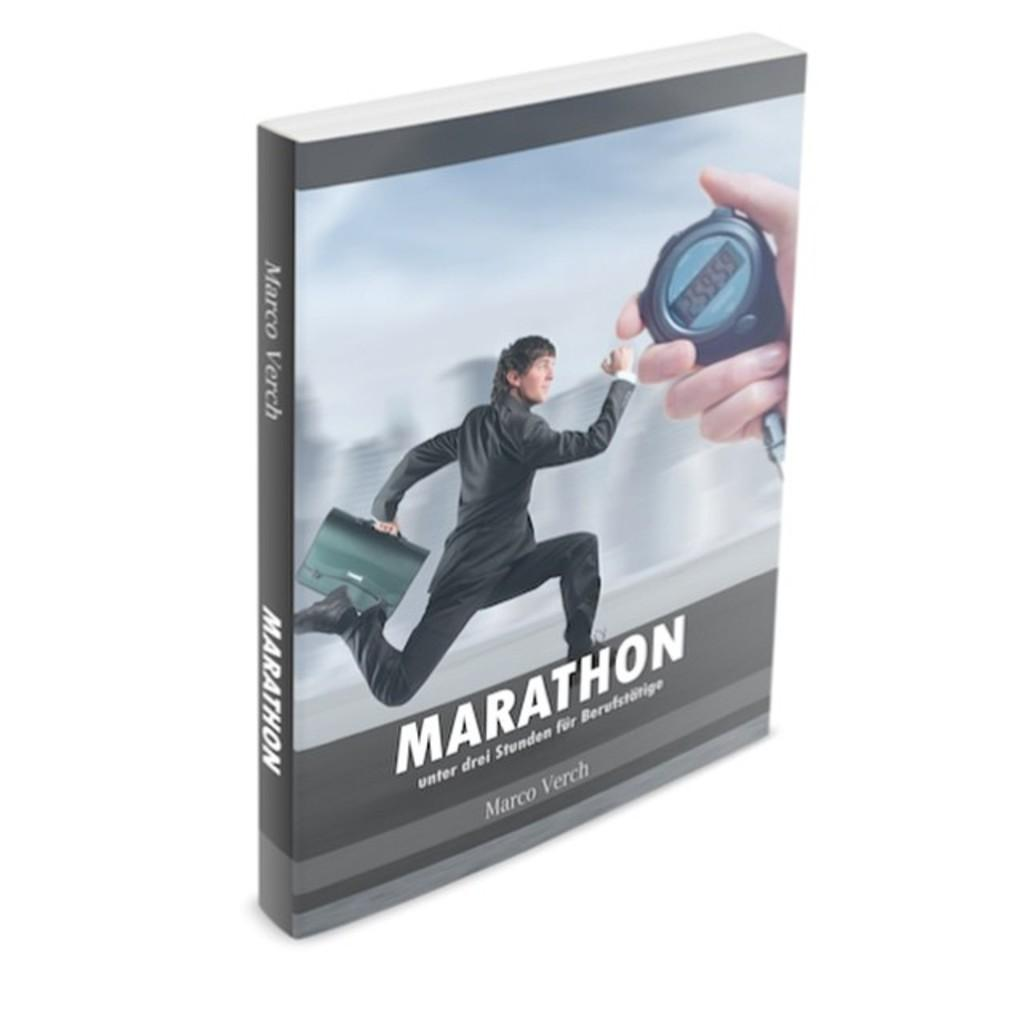<image>
Render a clear and concise summary of the photo. A book called Marathon has a stopwatch and a running man on the cover. 